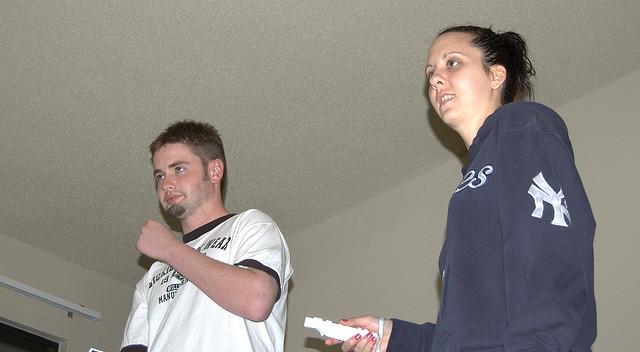What letters are on the woman's sleeve?
Write a very short answer. Ny. What is the girl's favorite team?
Short answer required. Yankees. How many people are sitting down?
Answer briefly. 0. How many men are here?
Concise answer only. 1. How many shirts is the man on the left wearing?
Concise answer only. 1. What color is the ribbing on the man's shirt?
Answer briefly. Black. 